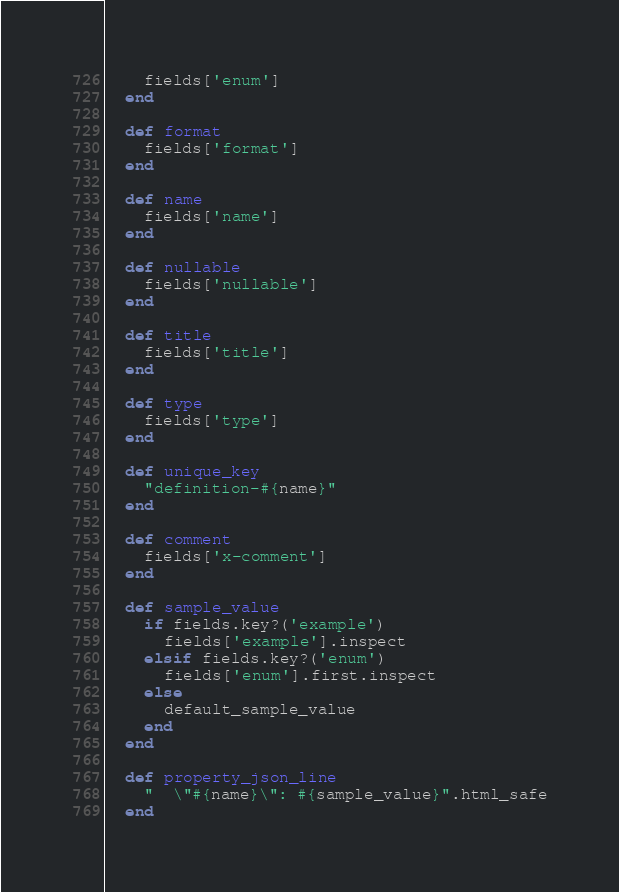Convert code to text. <code><loc_0><loc_0><loc_500><loc_500><_Ruby_>    fields['enum']
  end

  def format
    fields['format']
  end

  def name
    fields['name']
  end

  def nullable
    fields['nullable']
  end

  def title
    fields['title']
  end

  def type
    fields['type']
  end

  def unique_key
    "definition-#{name}"
  end

  def comment
    fields['x-comment']
  end

  def sample_value
    if fields.key?('example')
      fields['example'].inspect
    elsif fields.key?('enum')
      fields['enum'].first.inspect
    else
      default_sample_value
    end
  end

  def property_json_line
    "  \"#{name}\": #{sample_value}".html_safe
  end
</code> 